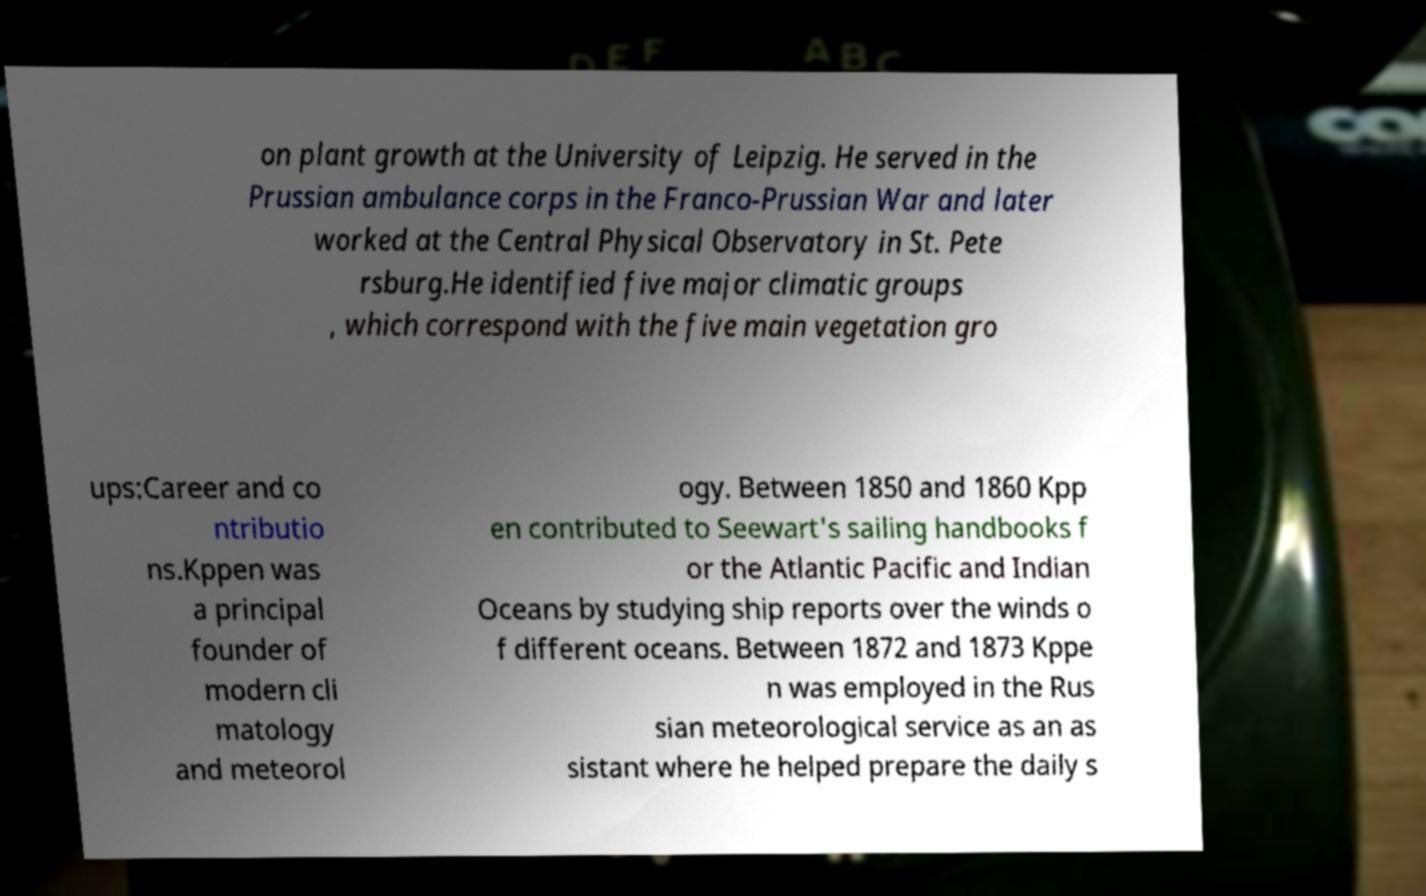There's text embedded in this image that I need extracted. Can you transcribe it verbatim? on plant growth at the University of Leipzig. He served in the Prussian ambulance corps in the Franco-Prussian War and later worked at the Central Physical Observatory in St. Pete rsburg.He identified five major climatic groups , which correspond with the five main vegetation gro ups:Career and co ntributio ns.Kppen was a principal founder of modern cli matology and meteorol ogy. Between 1850 and 1860 Kpp en contributed to Seewart's sailing handbooks f or the Atlantic Pacific and Indian Oceans by studying ship reports over the winds o f different oceans. Between 1872 and 1873 Kppe n was employed in the Rus sian meteorological service as an as sistant where he helped prepare the daily s 